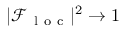Convert formula to latex. <formula><loc_0><loc_0><loc_500><loc_500>| \mathcal { F } _ { l o c } | ^ { 2 } \rightarrow 1</formula> 